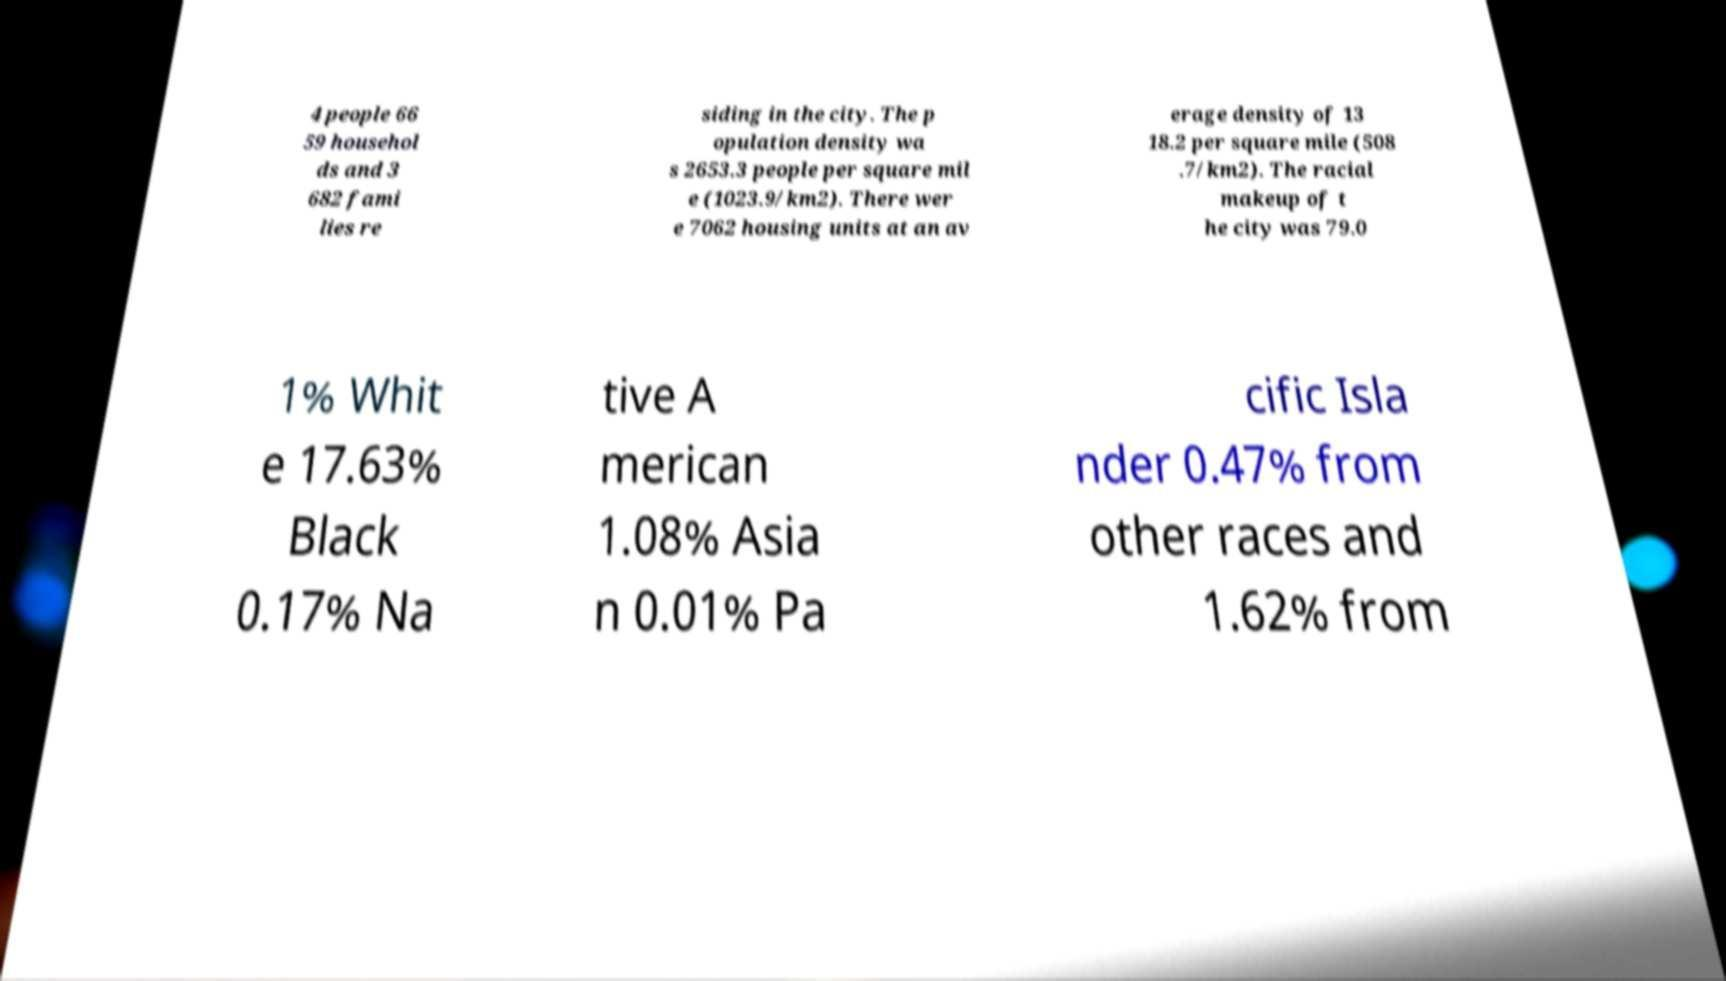Please identify and transcribe the text found in this image. 4 people 66 59 househol ds and 3 682 fami lies re siding in the city. The p opulation density wa s 2653.3 people per square mil e (1023.9/km2). There wer e 7062 housing units at an av erage density of 13 18.2 per square mile (508 .7/km2). The racial makeup of t he city was 79.0 1% Whit e 17.63% Black 0.17% Na tive A merican 1.08% Asia n 0.01% Pa cific Isla nder 0.47% from other races and 1.62% from 